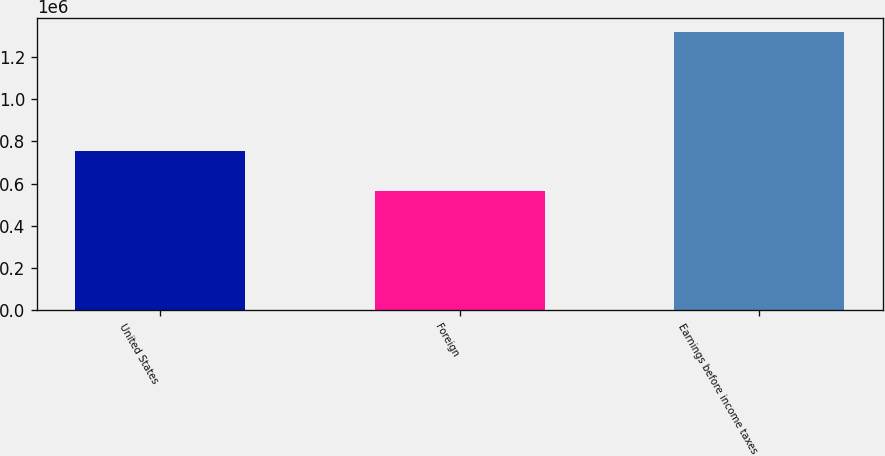Convert chart. <chart><loc_0><loc_0><loc_500><loc_500><bar_chart><fcel>United States<fcel>Foreign<fcel>Earnings before income taxes<nl><fcel>754562<fcel>563295<fcel>1.31786e+06<nl></chart> 